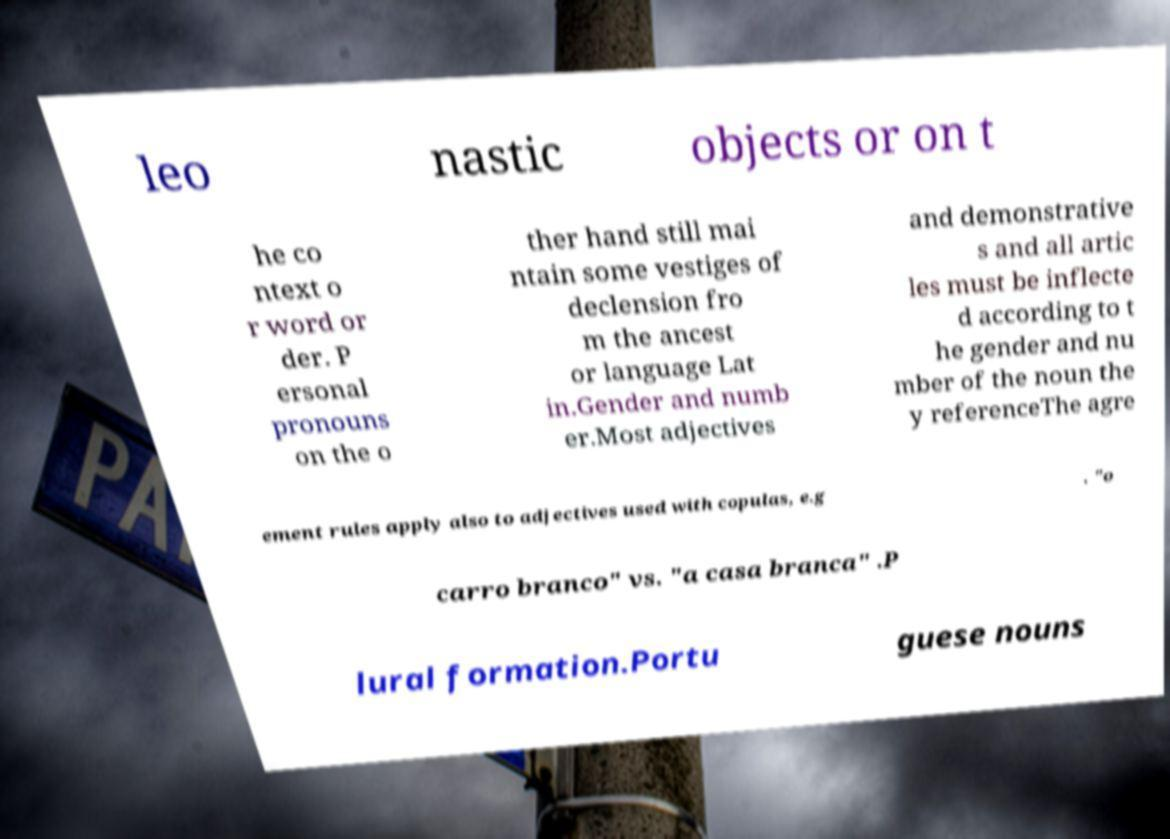Can you read and provide the text displayed in the image?This photo seems to have some interesting text. Can you extract and type it out for me? leo nastic objects or on t he co ntext o r word or der. P ersonal pronouns on the o ther hand still mai ntain some vestiges of declension fro m the ancest or language Lat in.Gender and numb er.Most adjectives and demonstrative s and all artic les must be inflecte d according to t he gender and nu mber of the noun the y referenceThe agre ement rules apply also to adjectives used with copulas, e.g . "o carro branco" vs. "a casa branca" .P lural formation.Portu guese nouns 